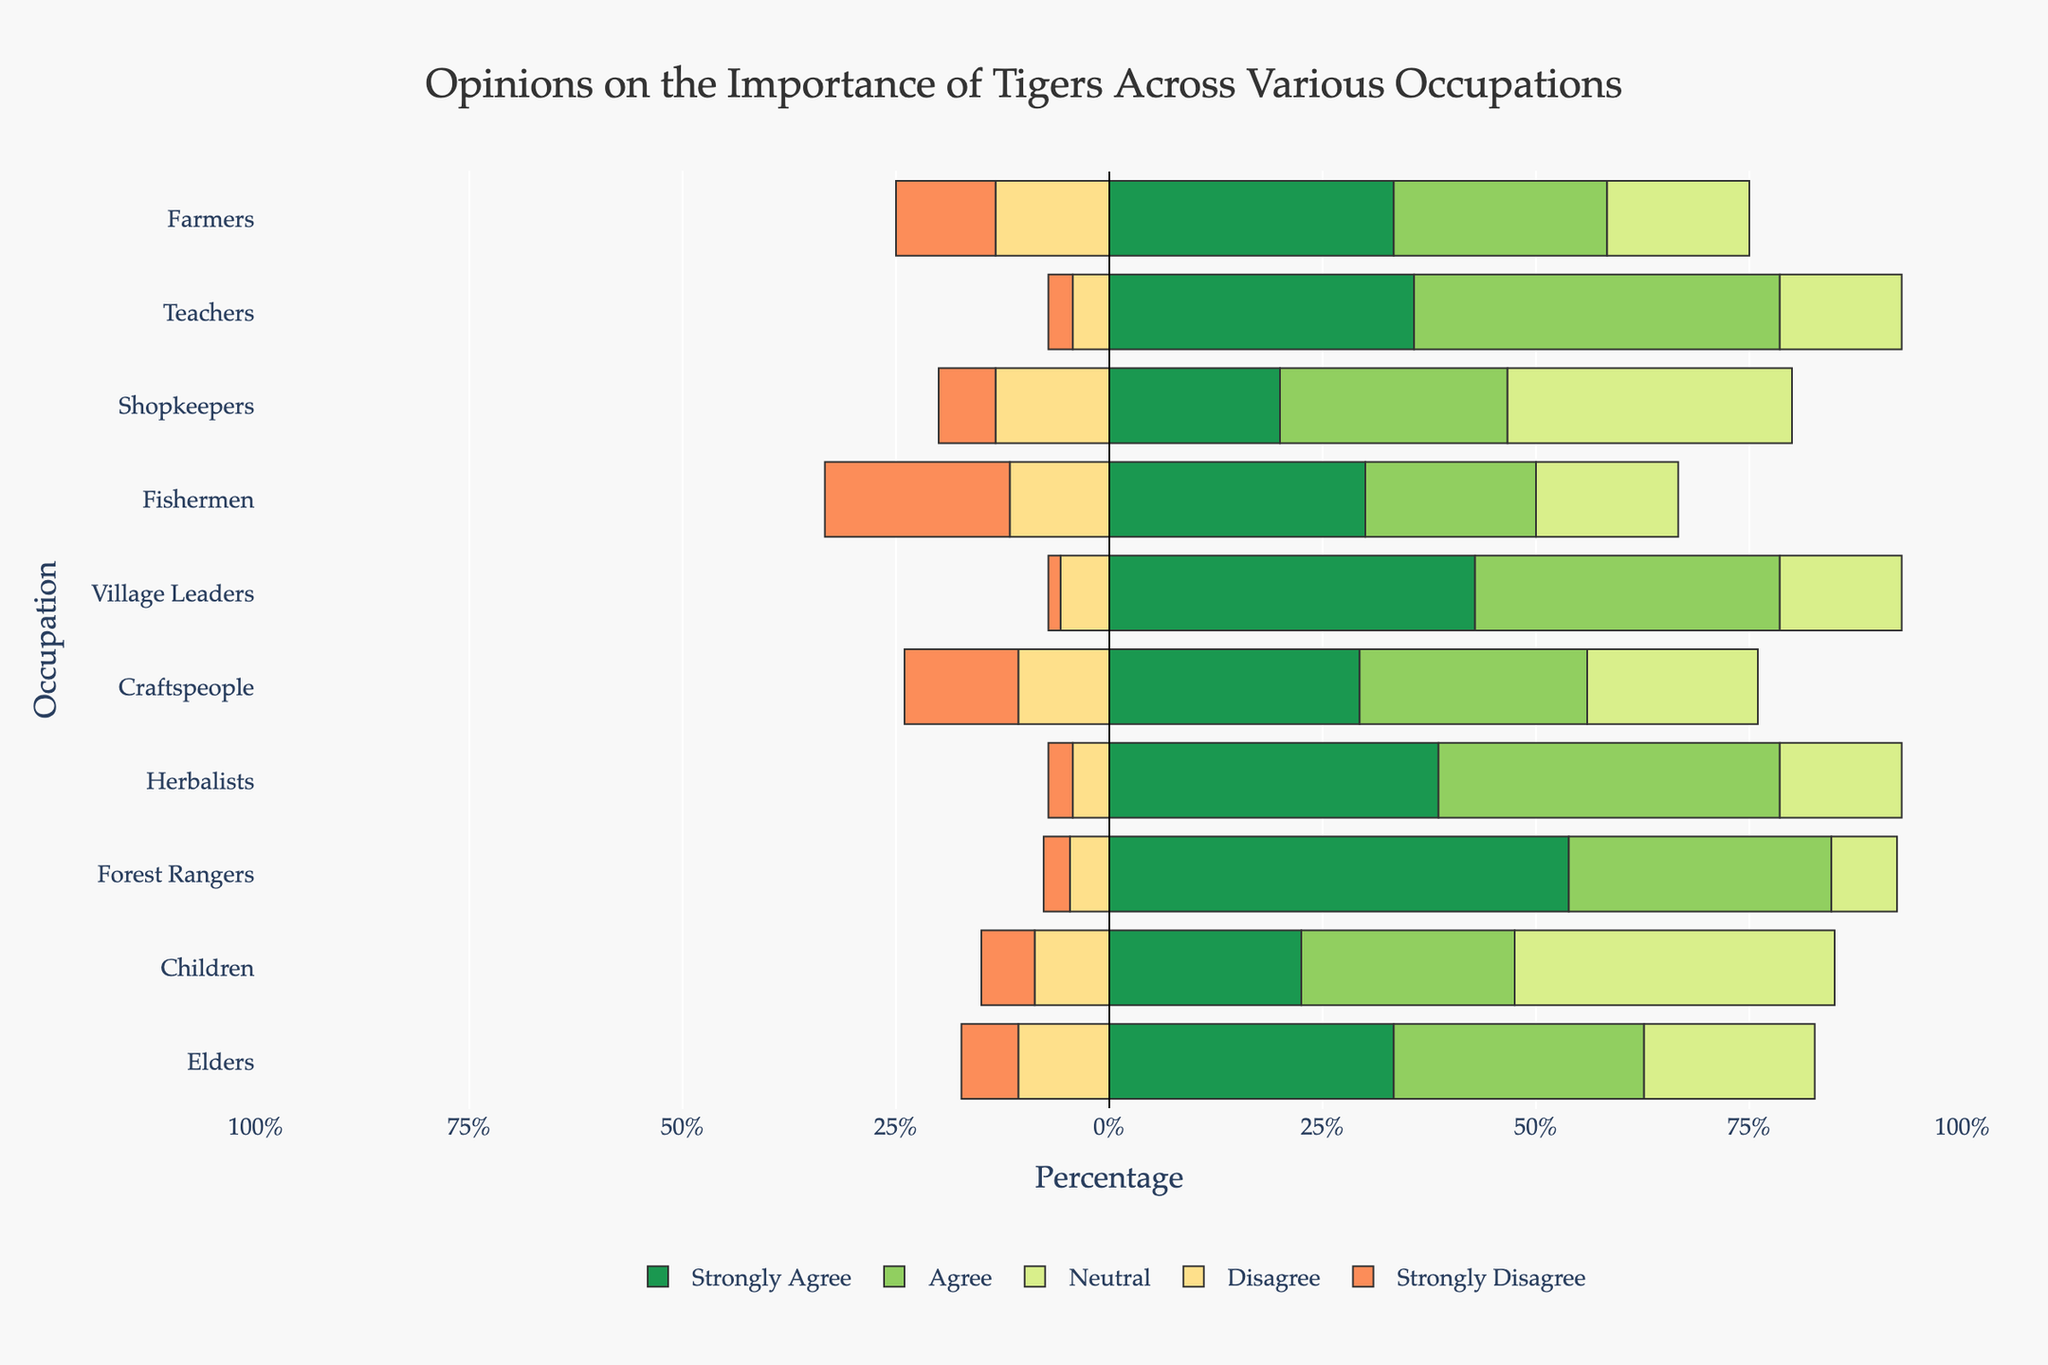Which occupation has the highest percentage of people who strongly agree on the importance of tigers? From the bar chart, observe which occupation's `Strongly Agree` section is longest. This should be the tallest green bar.
Answer: Forest Rangers Which two occupations have the highest combined percentage of people who either agree or strongly agree on the importance of tigers? Calculate the total percentage for `Agree` and `Strongly Agree` for each occupation by summing the lengths of the green and light green bars. The two highest sums belong to the selected occupations.
Answer: Herbalists and Teachers What is the total percentage of neutral opinions among Craftspeople and Shopkeepers? Find the percentage for `Neutral` for both Craftspeople and Shopkeepers (light yellow bars), then sum these percentages: for Craftspeople it's 15% and for Shopkeepers it's 25%, resulting in 15+25 = 40%.
Answer: 40% Which occupation agrees the least on the importance of tigers? Identify the occupation with the smallest `Agree` section (light green bar). This indicates the least agreement percentage.
Answer: Fishermen What is the difference in the percentage of people who strongly disagree between Village Leaders and Fishermen? Subtract the `Strongly Disagree` percentage of Village Leaders (orange-red bar) from Fishermen's. Village Leaders have 1% and Fishermen have 13%, so 13-1 = 12%.
Answer: 12% How do the percentages of neutral opinions compare for Children and Elders? Look at the `Neutral` bars for Children and Elders. Elders have 15%, and Children have 30%. Compare these percentages directly.
Answer: Children have a higher percentage Which occupation has the smallest combined percentage of people who disagree or strongly disagree on the importance of tigers? Add the `Disagree` and `Strongly Disagree` percentages for each occupation, and identify the occupation with the smallest sum.
Answer: Village Leaders Is there a visible trend among occupations about agreeing or strongly agreeing on the importance of tigers, such as specific job types (e.g., leadership roles) showing more agreement? Compare the `Agree` and `Strongly Agree` sections across occupations. Leadership roles such as Village Leaders and Herbalists show higher agreement percentages.
Answer: Yes, leadership roles show more agreement 